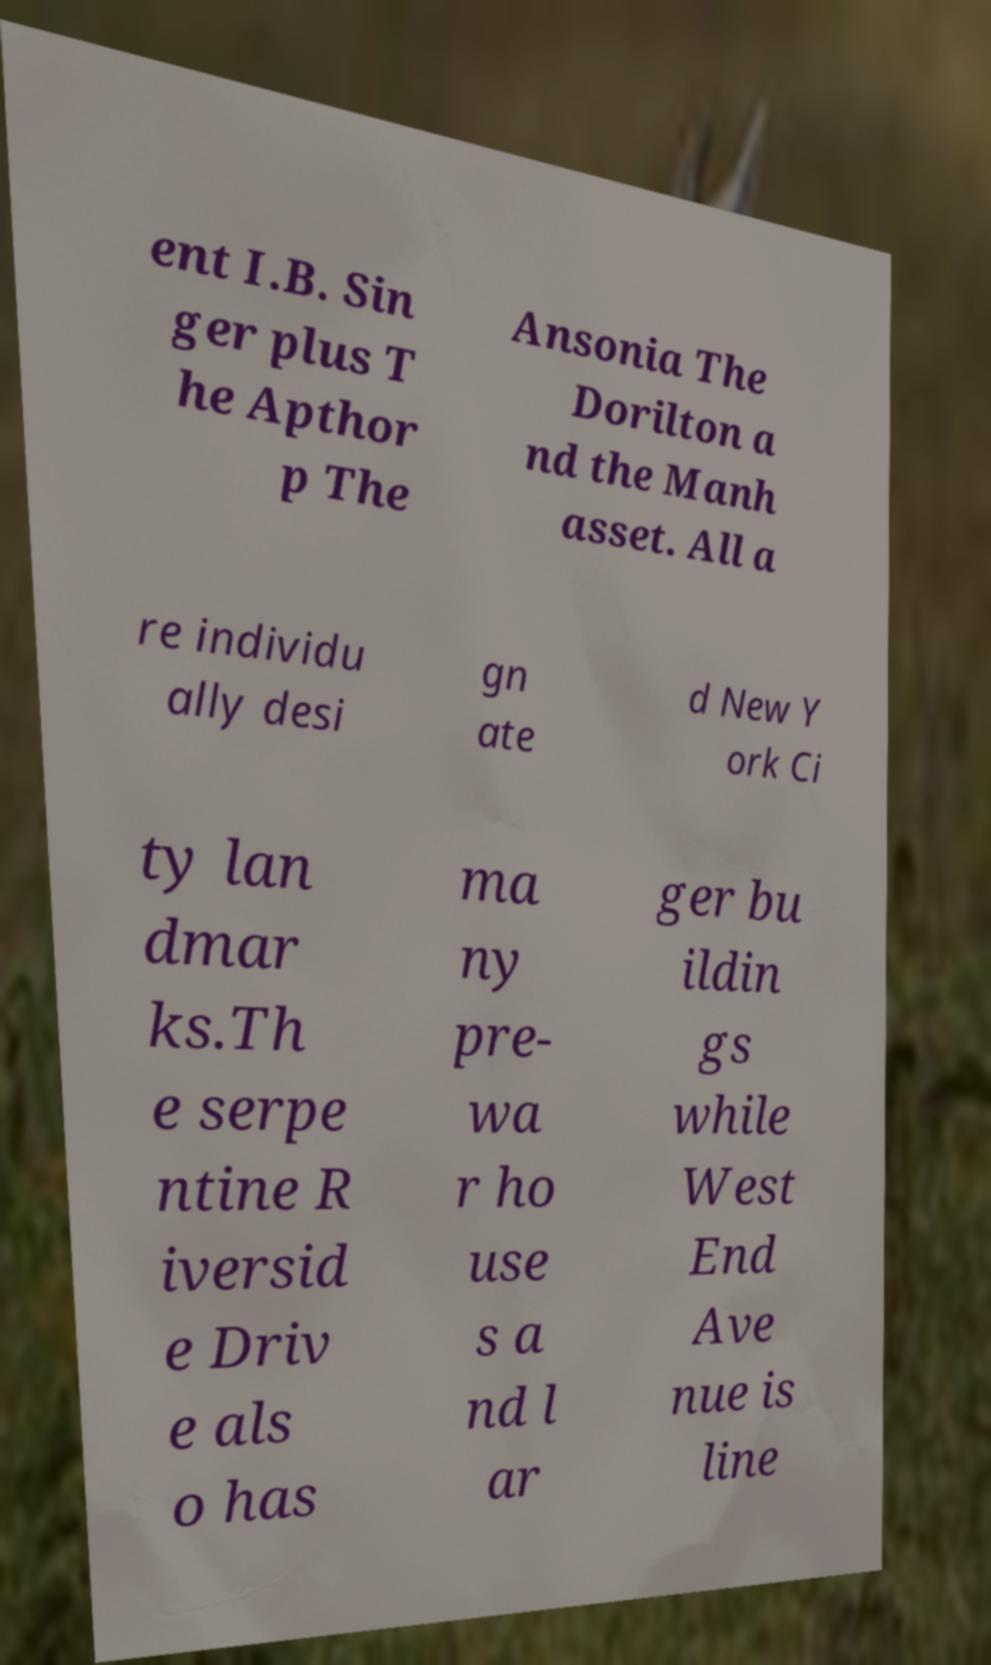Could you assist in decoding the text presented in this image and type it out clearly? ent I.B. Sin ger plus T he Apthor p The Ansonia The Dorilton a nd the Manh asset. All a re individu ally desi gn ate d New Y ork Ci ty lan dmar ks.Th e serpe ntine R iversid e Driv e als o has ma ny pre- wa r ho use s a nd l ar ger bu ildin gs while West End Ave nue is line 